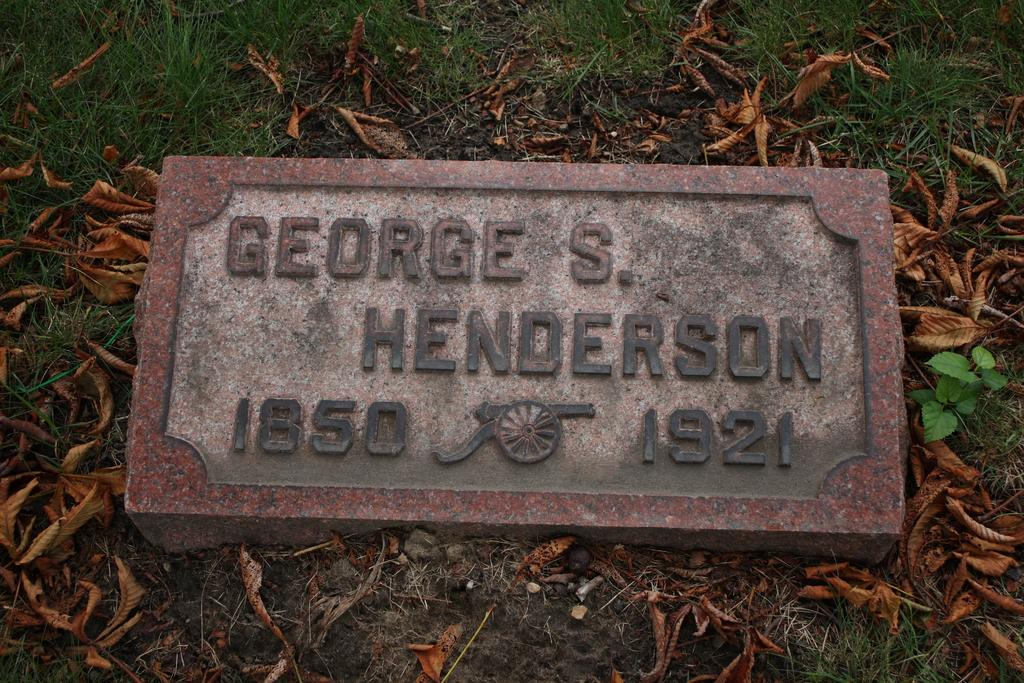What is the main subject in the center of the image? There is a gravestone in the center of the image. What can be seen on the ground around the gravestone? There are dry leaves and soil present in the image. Is there any vegetation in the image? Yes, there is a plant in the image. What type of ticket is visible on the gravestone in the image? There is no ticket present on the gravestone in the image. What kind of grass can be seen growing around the plant in the image? There is no grass visible in the image; only dry leaves and soil are present. 